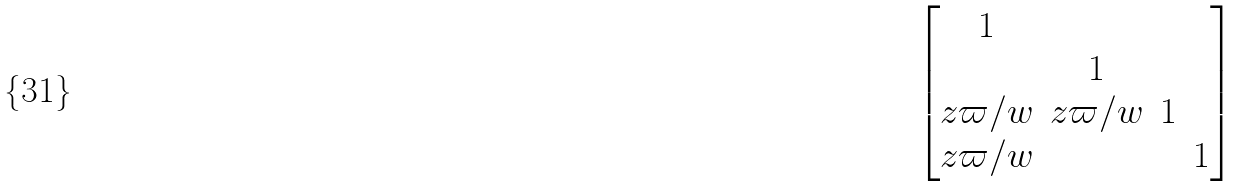<formula> <loc_0><loc_0><loc_500><loc_500>\begin{bmatrix} 1 \\ & 1 \\ z \varpi / w & z \varpi / w & 1 \\ z \varpi / w & & & 1 \end{bmatrix}</formula> 